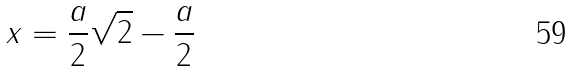<formula> <loc_0><loc_0><loc_500><loc_500>x = \frac { a } { 2 } \sqrt { 2 } - \frac { a } { 2 }</formula> 